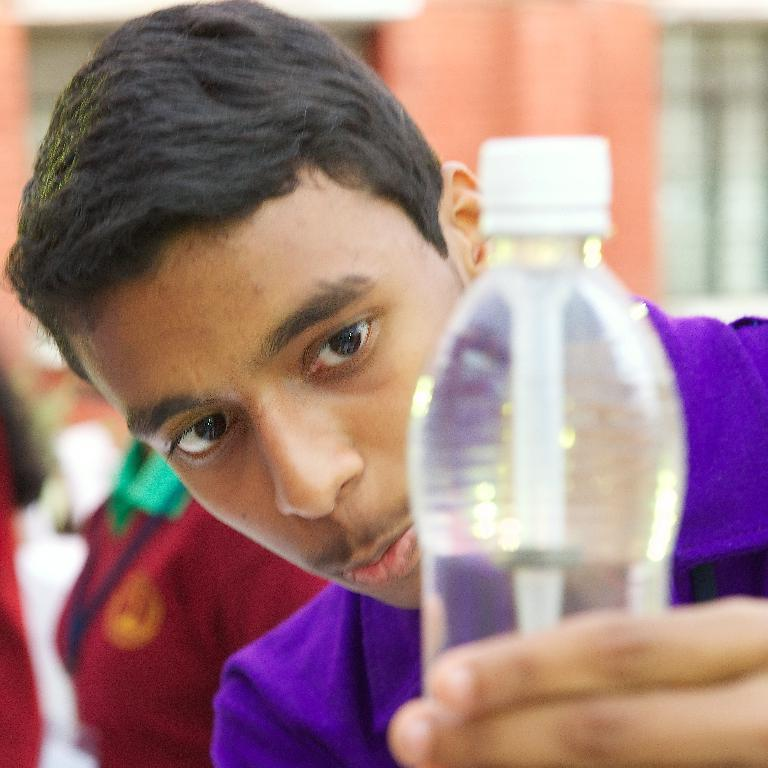Who is the main subject in the image? There is a boy in the image. What is the boy holding in his left hand? The boy is holding a water bottle in his left hand. What is the boy's focus in the image? The boy is looking at the water bottle. What can be seen in the background of the image? There are people and a building in the background of the image. What type of cherries can be seen burning in the image? There are no cherries or any indication of fire or burning in the image. 